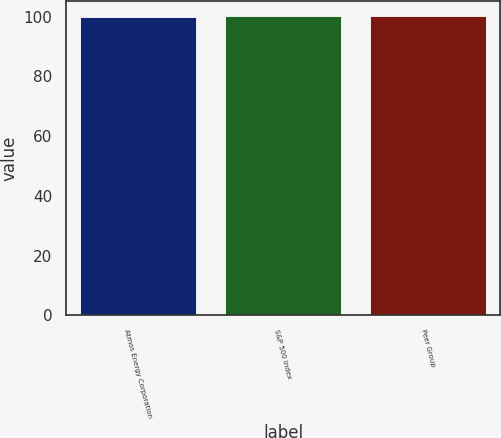<chart> <loc_0><loc_0><loc_500><loc_500><bar_chart><fcel>Atmos Energy Corporation<fcel>S&P 500 Index<fcel>Peer Group<nl><fcel>100<fcel>100.1<fcel>100.2<nl></chart> 